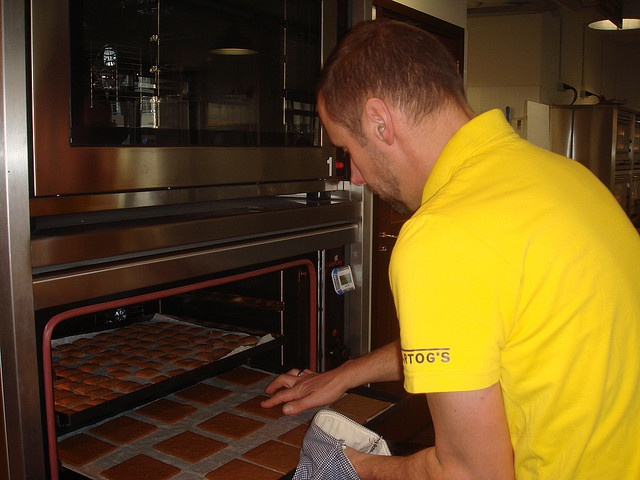Describe the objects in this image and their specific colors. I can see oven in maroon, black, and gray tones, people in maroon, gold, and brown tones, and microwave in maroon, black, and gray tones in this image. 